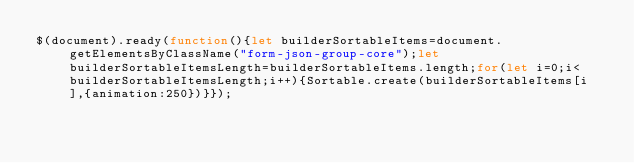Convert code to text. <code><loc_0><loc_0><loc_500><loc_500><_JavaScript_>$(document).ready(function(){let builderSortableItems=document.getElementsByClassName("form-json-group-core");let builderSortableItemsLength=builderSortableItems.length;for(let i=0;i<builderSortableItemsLength;i++){Sortable.create(builderSortableItems[i],{animation:250})}});</code> 